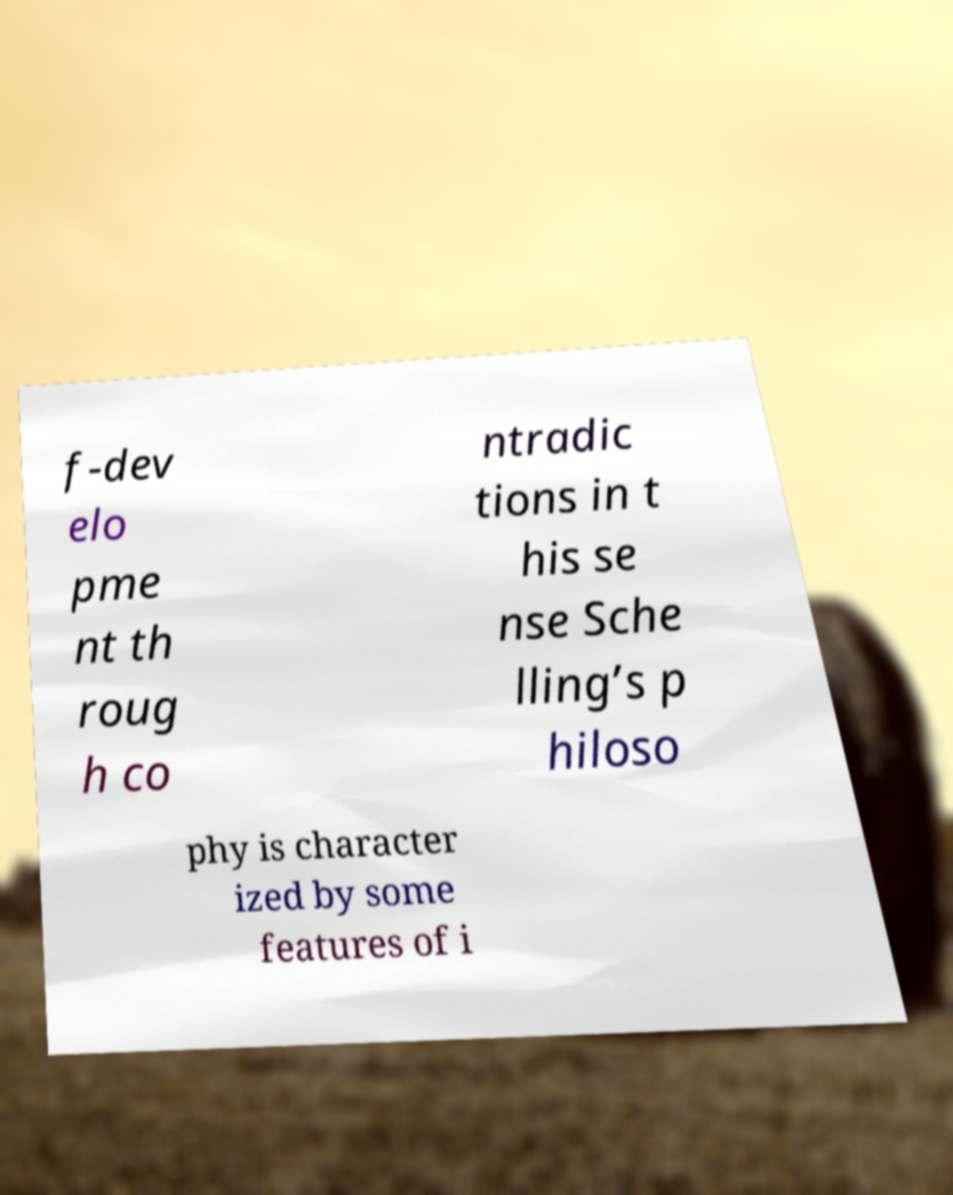Could you assist in decoding the text presented in this image and type it out clearly? f-dev elo pme nt th roug h co ntradic tions in t his se nse Sche lling’s p hiloso phy is character ized by some features of i 